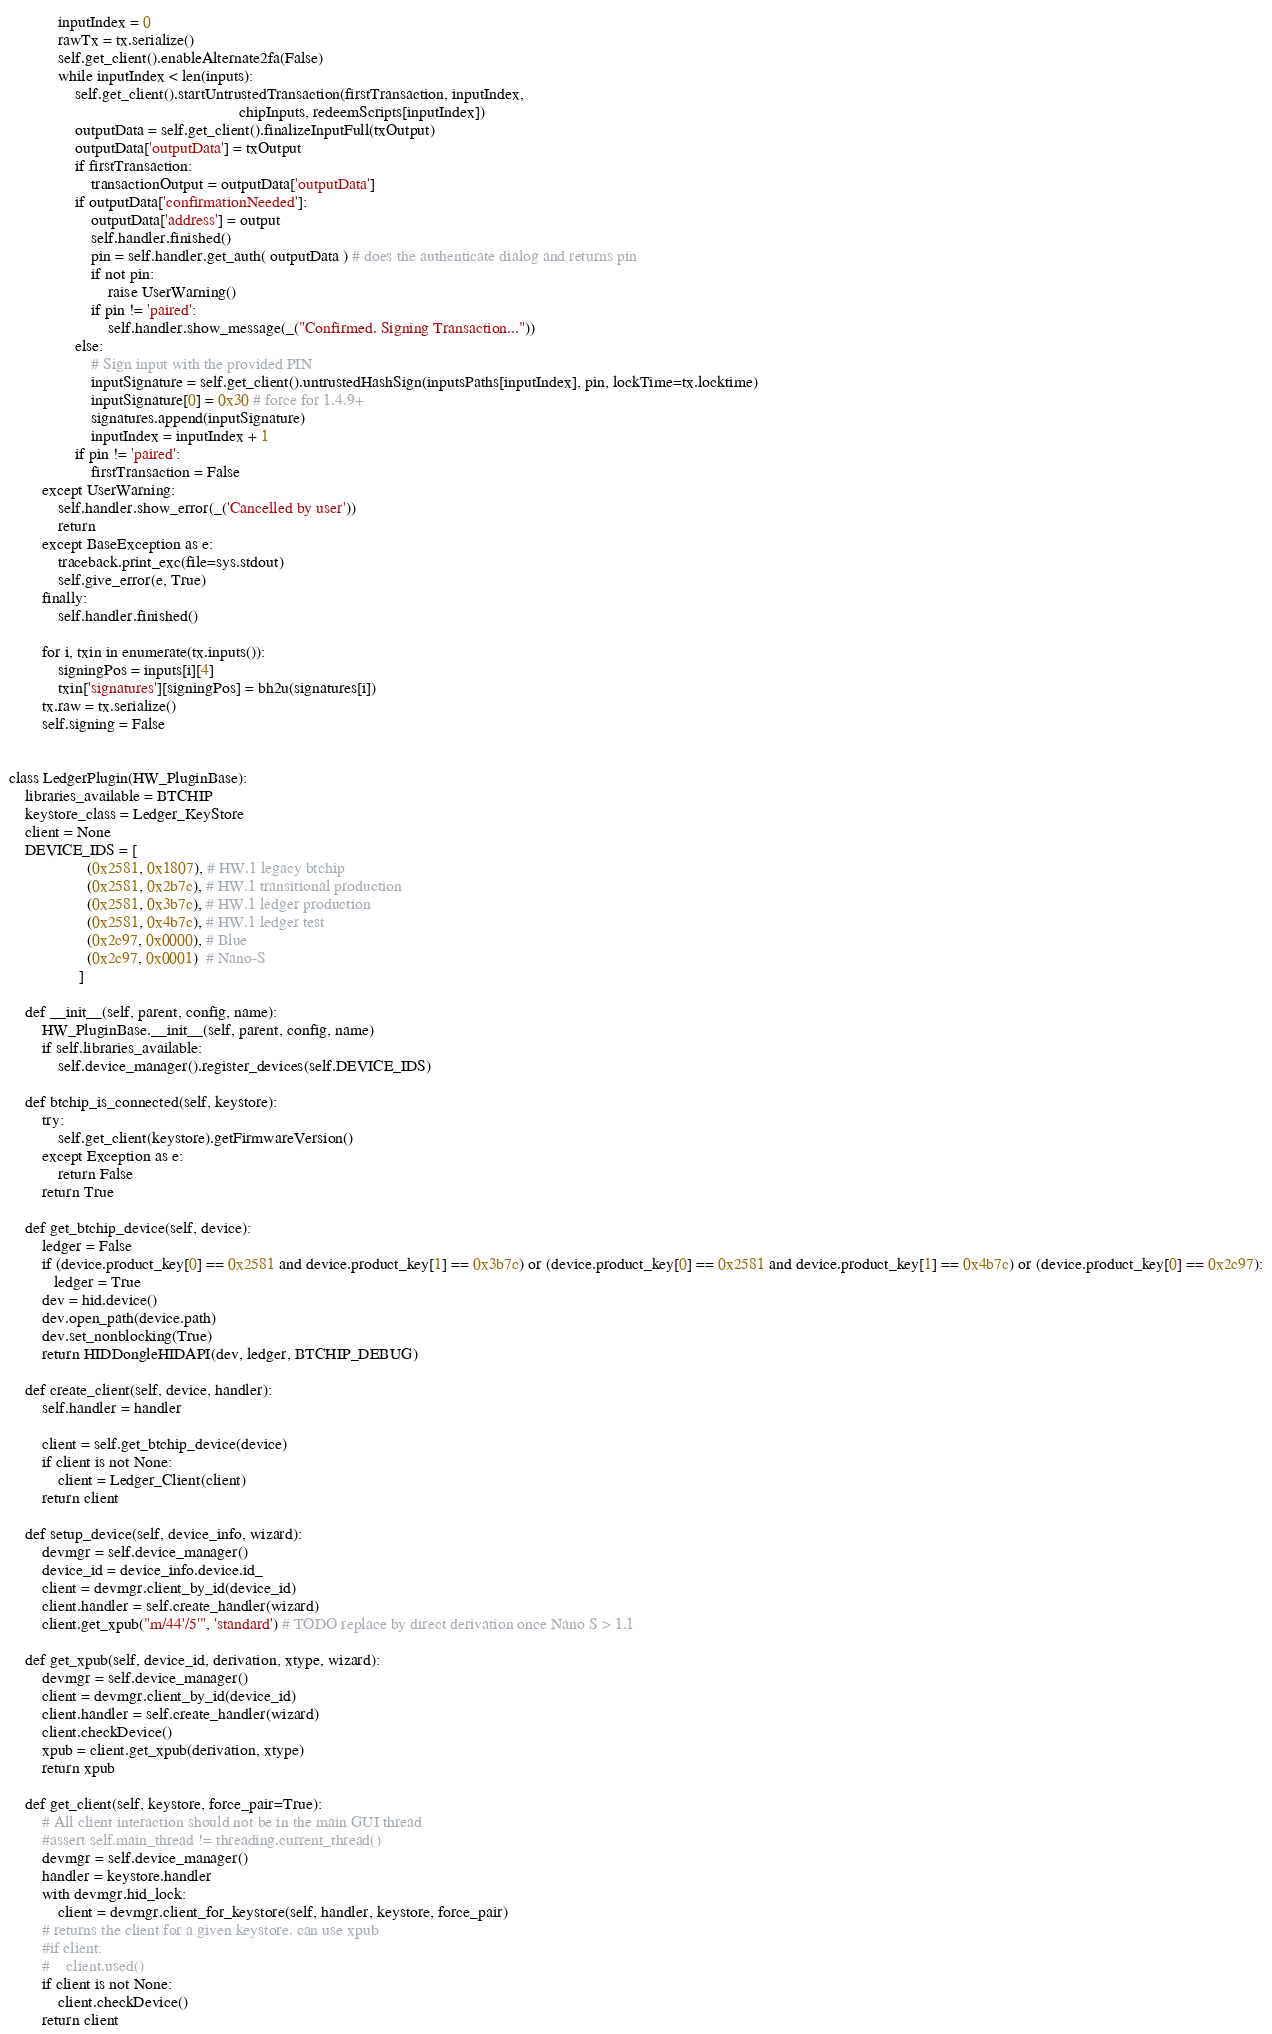<code> <loc_0><loc_0><loc_500><loc_500><_Python_>            inputIndex = 0
            rawTx = tx.serialize()
            self.get_client().enableAlternate2fa(False)
            while inputIndex < len(inputs):
                self.get_client().startUntrustedTransaction(firstTransaction, inputIndex,
                                                        chipInputs, redeemScripts[inputIndex])
                outputData = self.get_client().finalizeInputFull(txOutput)
                outputData['outputData'] = txOutput
                if firstTransaction:
                    transactionOutput = outputData['outputData']
                if outputData['confirmationNeeded']:
                    outputData['address'] = output
                    self.handler.finished()
                    pin = self.handler.get_auth( outputData ) # does the authenticate dialog and returns pin
                    if not pin:
                        raise UserWarning()
                    if pin != 'paired':
                        self.handler.show_message(_("Confirmed. Signing Transaction..."))
                else:
                    # Sign input with the provided PIN
                    inputSignature = self.get_client().untrustedHashSign(inputsPaths[inputIndex], pin, lockTime=tx.locktime)
                    inputSignature[0] = 0x30 # force for 1.4.9+
                    signatures.append(inputSignature)
                    inputIndex = inputIndex + 1
                if pin != 'paired':
                    firstTransaction = False
        except UserWarning:
            self.handler.show_error(_('Cancelled by user'))
            return
        except BaseException as e:
            traceback.print_exc(file=sys.stdout)
            self.give_error(e, True)
        finally:
            self.handler.finished()

        for i, txin in enumerate(tx.inputs()):
            signingPos = inputs[i][4]
            txin['signatures'][signingPos] = bh2u(signatures[i])
        tx.raw = tx.serialize()
        self.signing = False


class LedgerPlugin(HW_PluginBase):
    libraries_available = BTCHIP
    keystore_class = Ledger_KeyStore
    client = None
    DEVICE_IDS = [
                   (0x2581, 0x1807), # HW.1 legacy btchip
                   (0x2581, 0x2b7c), # HW.1 transitional production
                   (0x2581, 0x3b7c), # HW.1 ledger production
                   (0x2581, 0x4b7c), # HW.1 ledger test
                   (0x2c97, 0x0000), # Blue
                   (0x2c97, 0x0001)  # Nano-S
                 ]

    def __init__(self, parent, config, name):
        HW_PluginBase.__init__(self, parent, config, name)
        if self.libraries_available:
            self.device_manager().register_devices(self.DEVICE_IDS)

    def btchip_is_connected(self, keystore):
        try:
            self.get_client(keystore).getFirmwareVersion()
        except Exception as e:
            return False
        return True

    def get_btchip_device(self, device):
        ledger = False
        if (device.product_key[0] == 0x2581 and device.product_key[1] == 0x3b7c) or (device.product_key[0] == 0x2581 and device.product_key[1] == 0x4b7c) or (device.product_key[0] == 0x2c97):
           ledger = True
        dev = hid.device()
        dev.open_path(device.path)
        dev.set_nonblocking(True)
        return HIDDongleHIDAPI(dev, ledger, BTCHIP_DEBUG)

    def create_client(self, device, handler):
        self.handler = handler

        client = self.get_btchip_device(device)
        if client is not None:
            client = Ledger_Client(client)
        return client

    def setup_device(self, device_info, wizard):
        devmgr = self.device_manager()
        device_id = device_info.device.id_
        client = devmgr.client_by_id(device_id)
        client.handler = self.create_handler(wizard)
        client.get_xpub("m/44'/5'", 'standard') # TODO replace by direct derivation once Nano S > 1.1

    def get_xpub(self, device_id, derivation, xtype, wizard):
        devmgr = self.device_manager()
        client = devmgr.client_by_id(device_id)
        client.handler = self.create_handler(wizard)
        client.checkDevice()
        xpub = client.get_xpub(derivation, xtype)
        return xpub

    def get_client(self, keystore, force_pair=True):
        # All client interaction should not be in the main GUI thread
        #assert self.main_thread != threading.current_thread()
        devmgr = self.device_manager()
        handler = keystore.handler
        with devmgr.hid_lock:
            client = devmgr.client_for_keystore(self, handler, keystore, force_pair)
        # returns the client for a given keystore. can use xpub
        #if client:
        #    client.used()
        if client is not None:
            client.checkDevice()
        return client
</code> 